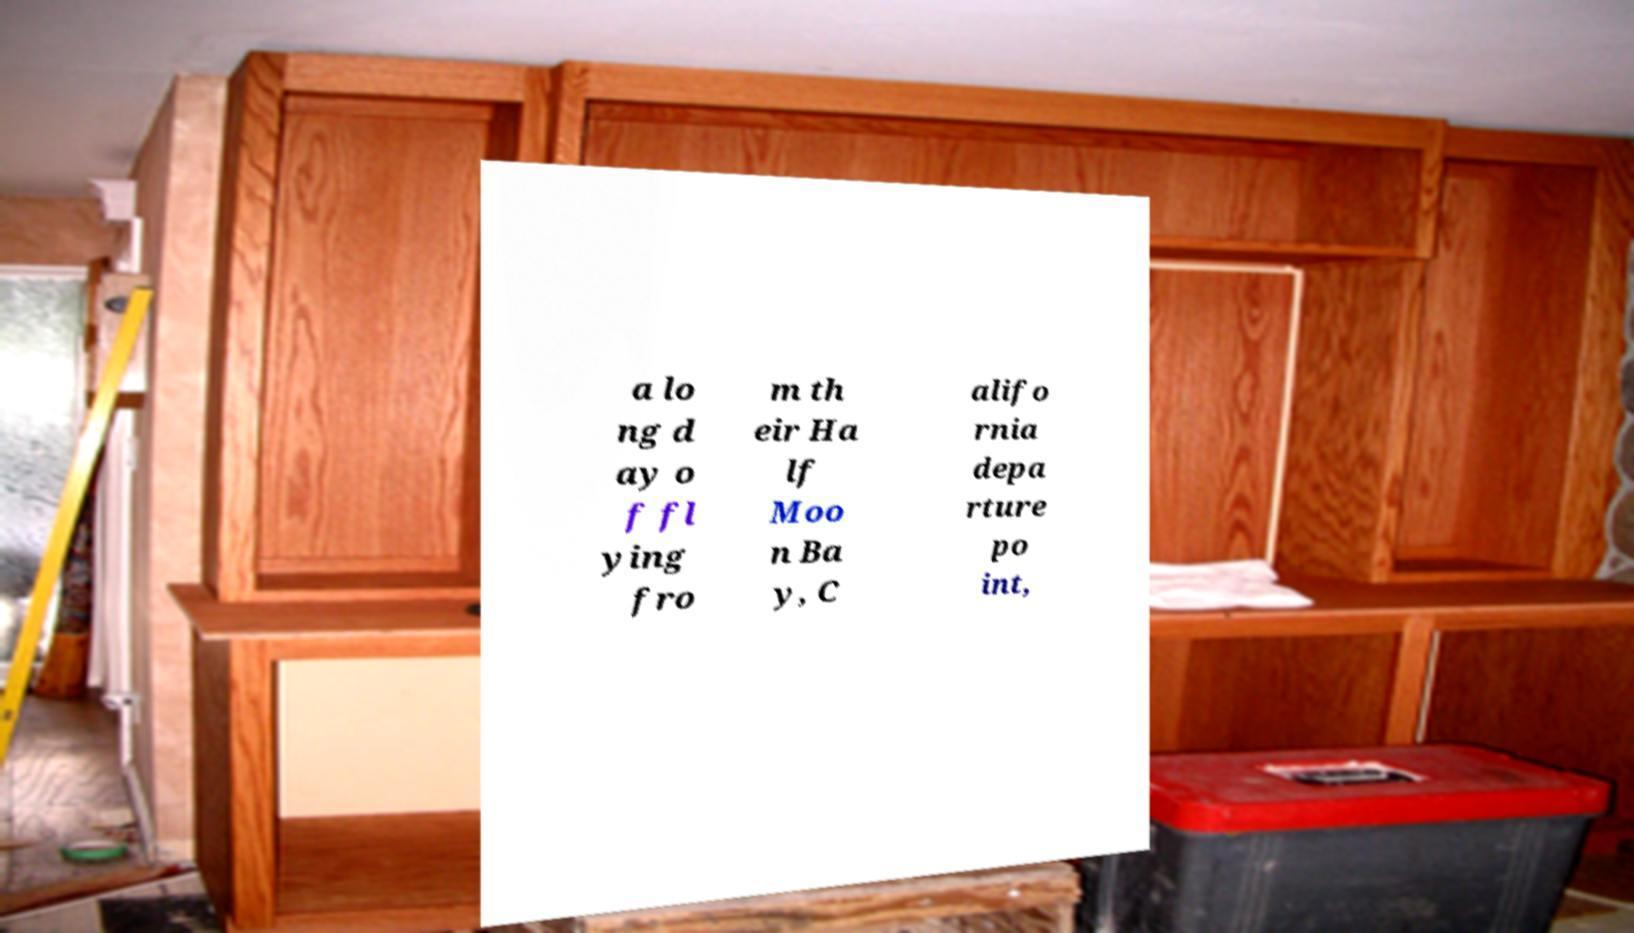Could you assist in decoding the text presented in this image and type it out clearly? a lo ng d ay o f fl ying fro m th eir Ha lf Moo n Ba y, C alifo rnia depa rture po int, 